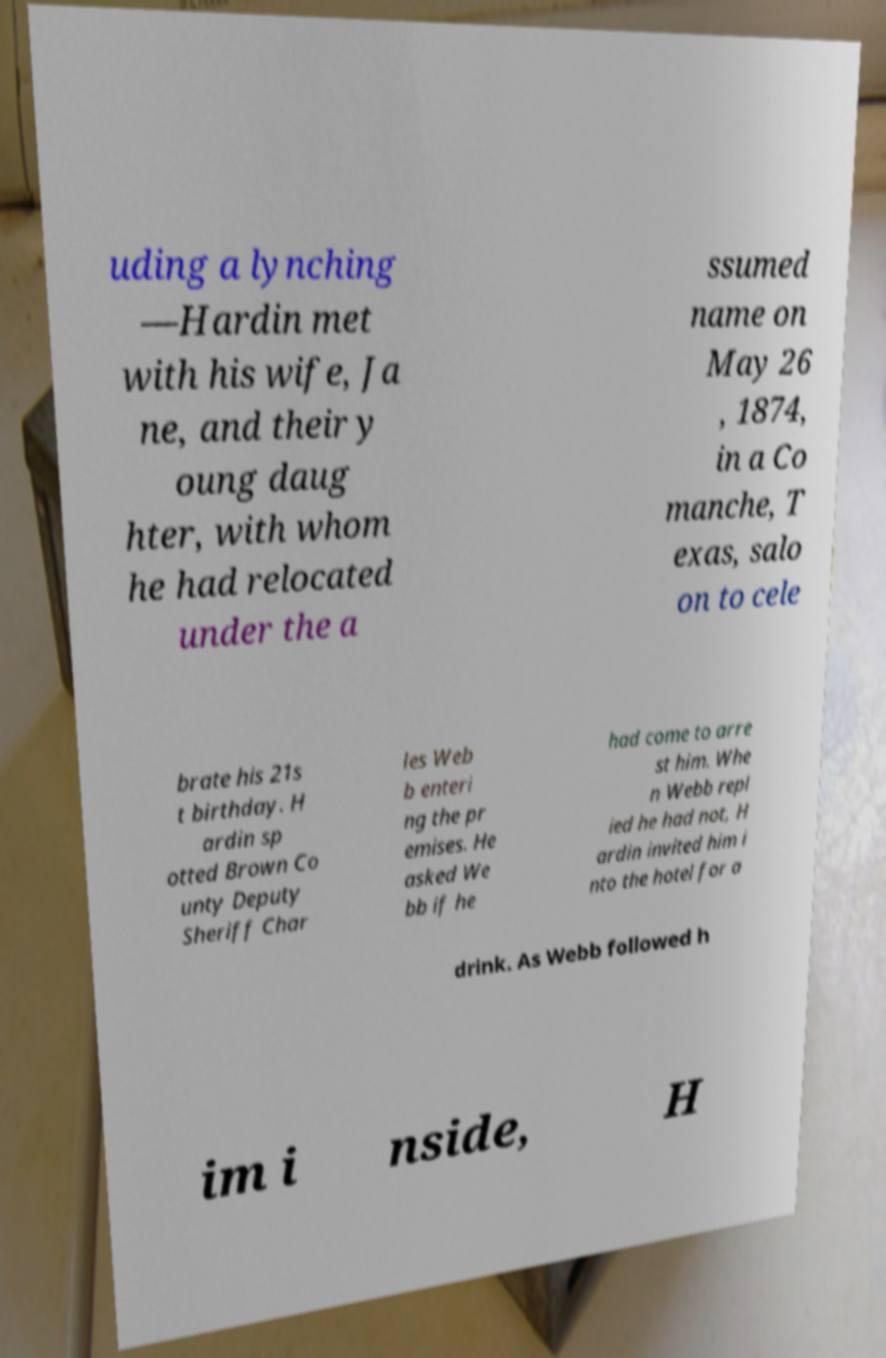For documentation purposes, I need the text within this image transcribed. Could you provide that? uding a lynching —Hardin met with his wife, Ja ne, and their y oung daug hter, with whom he had relocated under the a ssumed name on May 26 , 1874, in a Co manche, T exas, salo on to cele brate his 21s t birthday. H ardin sp otted Brown Co unty Deputy Sheriff Char les Web b enteri ng the pr emises. He asked We bb if he had come to arre st him. Whe n Webb repl ied he had not, H ardin invited him i nto the hotel for a drink. As Webb followed h im i nside, H 